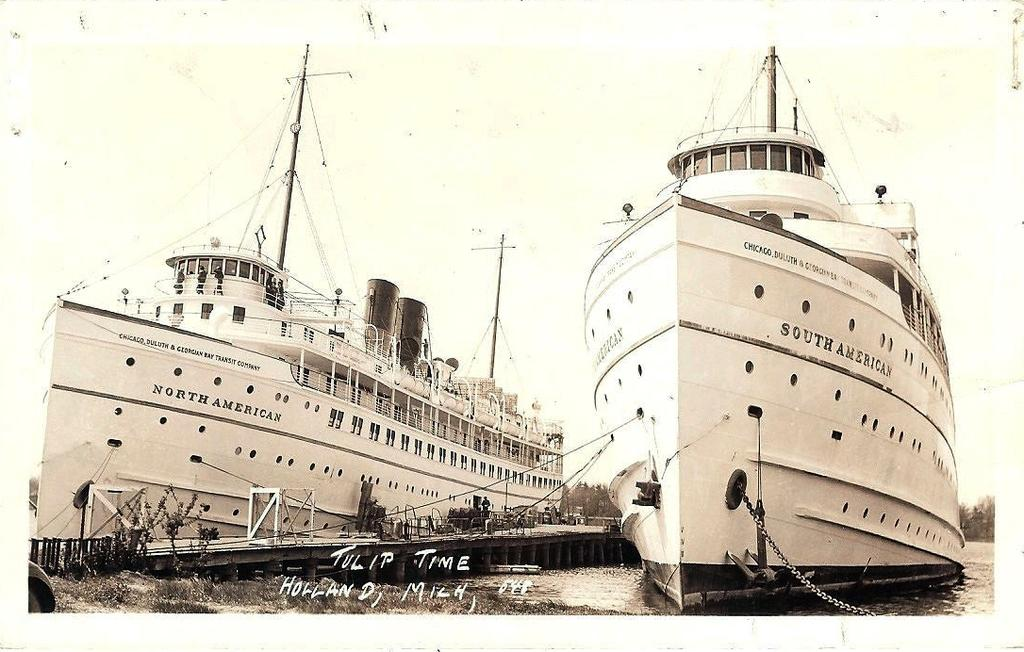<image>
Present a compact description of the photo's key features. A North American and South American ship next to each other. 